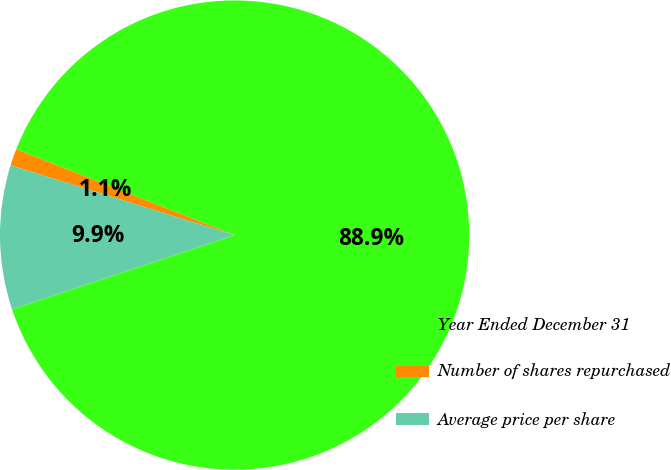Convert chart to OTSL. <chart><loc_0><loc_0><loc_500><loc_500><pie_chart><fcel>Year Ended December 31<fcel>Number of shares repurchased<fcel>Average price per share<nl><fcel>88.92%<fcel>1.15%<fcel>9.93%<nl></chart> 